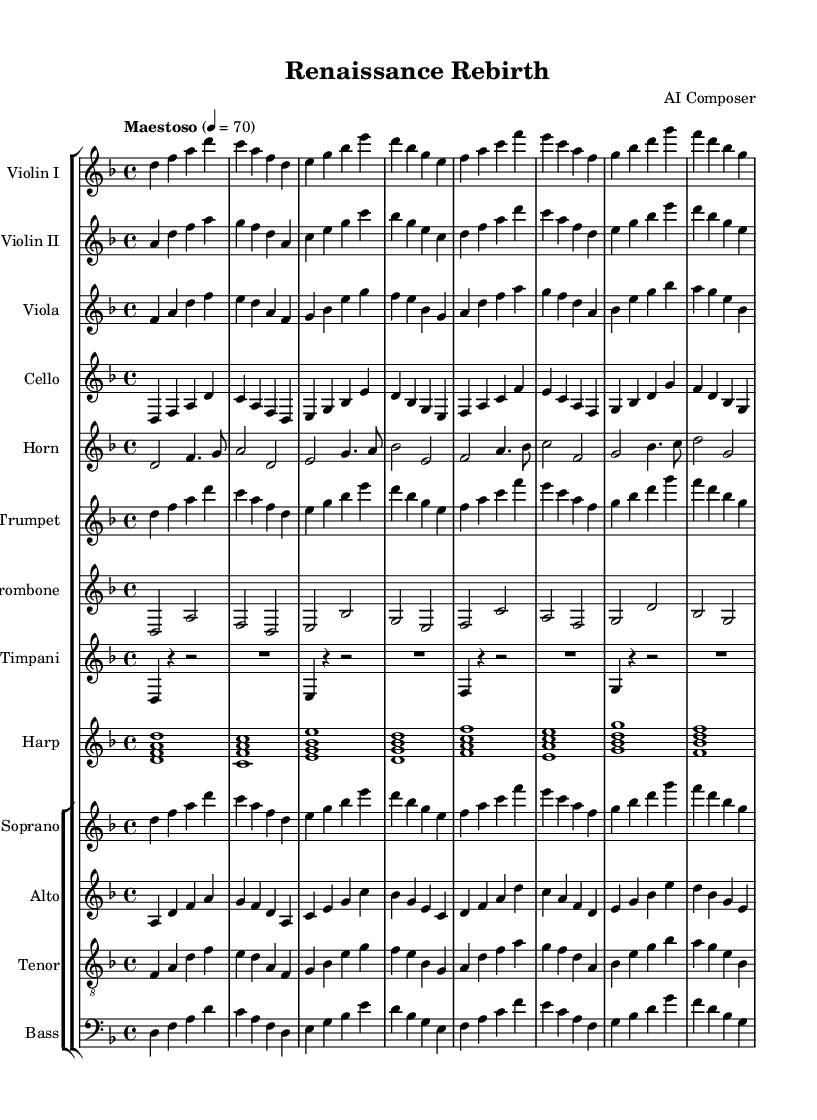What is the key signature of this music? The key signature is determined by looking at the beginning of the staff where the sharp or flat symbols are placed. Here, there are no sharps or flats indicated, which means it is in the key of D minor.
Answer: D minor What is the time signature of this music? The time signature can be found at the beginning of the staff and is represented by the numbers stacked atop each other. Here, the numbers indicate that there are four beats in each measure, with a quarter note getting one beat, so the time signature is 4/4.
Answer: 4/4 What tempo marking is given in the score? The tempo marking is typically indicated at the beginning of the score, often in Italian. In this case, it says "Maestoso," which suggests a majestic and grand tempo, along with the numeric indication of 70 beats per minute.
Answer: Maestoso Which instrument has the highest pitch in this score? To determine the highest pitch, one can compare the ranges of each instrument part in the score. The Sopranos typically sing in higher pitches than the other instruments, making it the highest in this score.
Answer: Soprano How many measures are in the full score? To find the number of measures, we count the measures in one of the instrumental parts and see if they match across the other voices. Each part has multiple measures repeated similarly, and counting any part gives a total of eight measures across the score.
Answer: 8 Which instrument plays the timpani part? The timpani part is specifically labeled in the score by its instrument name. Looking closely, there is a dedicated staff that indicates "Timpani" which confirms its position in the orchestration.
Answer: Timpani What compositional technique is mainly used in the string sections? The string sections feature a common compositional technique called "homophony," where all string instruments play harmonies in a coordinated manner, creating a fuller sound.
Answer: Homophony 